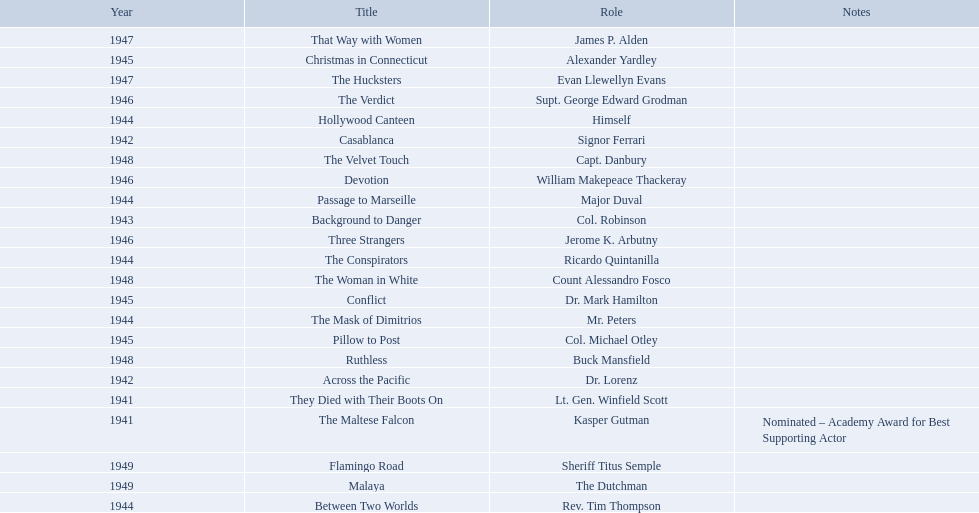What are all of the movies sydney greenstreet acted in? The Maltese Falcon, They Died with Their Boots On, Across the Pacific, Casablanca, Background to Danger, Passage to Marseille, Between Two Worlds, The Mask of Dimitrios, The Conspirators, Hollywood Canteen, Pillow to Post, Conflict, Christmas in Connecticut, Three Strangers, Devotion, The Verdict, That Way with Women, The Hucksters, The Velvet Touch, Ruthless, The Woman in White, Flamingo Road, Malaya. What are all of the title notes? Nominated – Academy Award for Best Supporting Actor. Which film was the award for? The Maltese Falcon. 